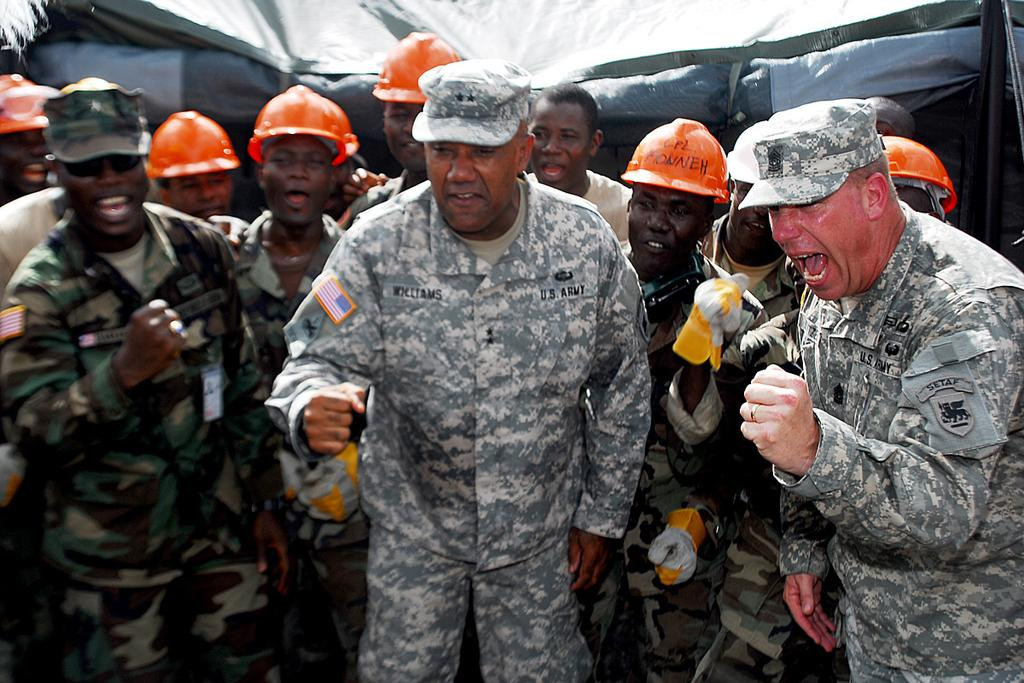What is the main subject of the image? The main subject of the image is a group of people. What are the people in the image doing? The people are standing. What color tint can be seen in the background of the image? There is a black color tint in the background of the image. What is the opinion of the people in the image about the recent test results? There is no information about opinions or test results in the image, so it cannot be determined from the image. 